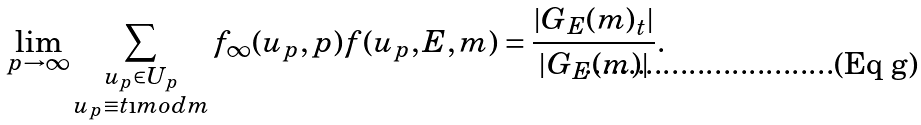Convert formula to latex. <formula><loc_0><loc_0><loc_500><loc_500>\lim _ { p \rightarrow \infty } \sum _ { \substack { { u } _ { p } \in U _ { p } \\ { u } _ { p } \equiv t \i m o d { m } } } f _ { \infty } ( { u } _ { p } , p ) f { ( { u } _ { p } , { E } , m ) } = \frac { | { { G _ { E } } ( m ) } _ { t } | } { { | G _ { E } } ( m ) | } .</formula> 